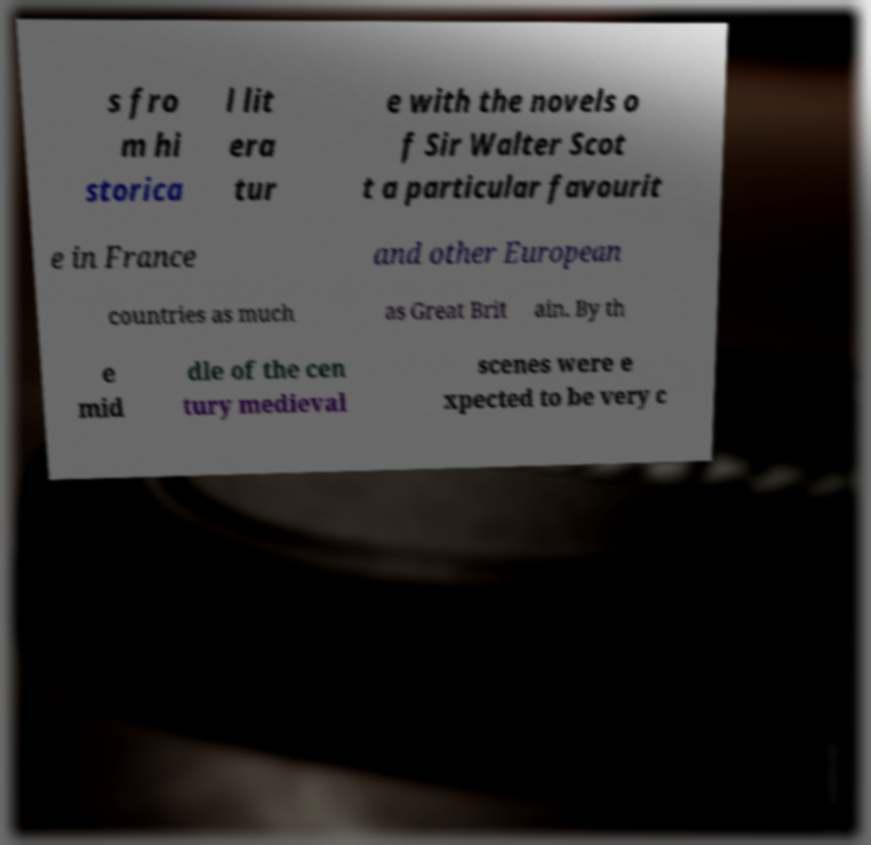For documentation purposes, I need the text within this image transcribed. Could you provide that? s fro m hi storica l lit era tur e with the novels o f Sir Walter Scot t a particular favourit e in France and other European countries as much as Great Brit ain. By th e mid dle of the cen tury medieval scenes were e xpected to be very c 